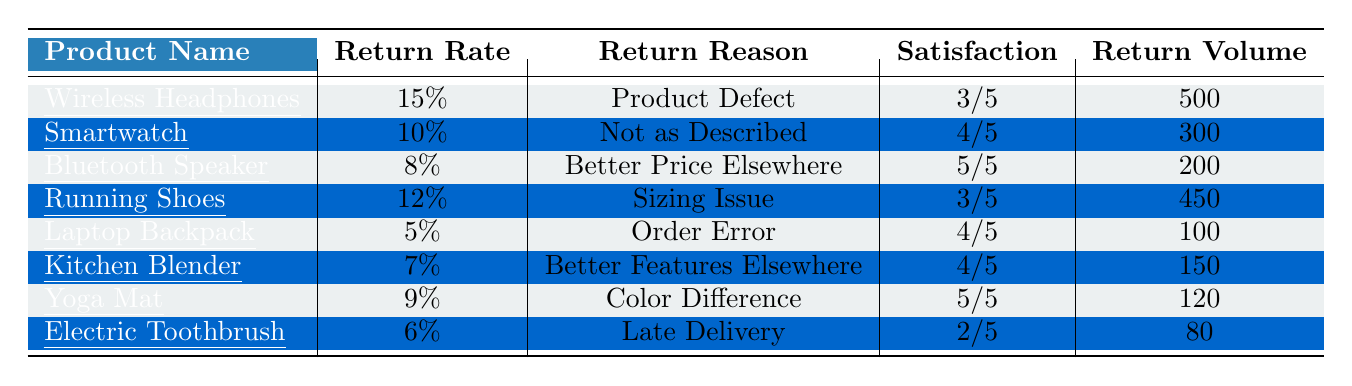What is the return rate for Wireless Headphones? The table directly lists the return rate for Wireless Headphones as 15%.
Answer: 15% What is the return reason for the Smartwatch? The return reason for the Smartwatch, as stated in the table, is "Not as Described."
Answer: Not as Described Which product has the highest customer satisfaction score? The customer satisfaction scores in the table show that the Bluetooth Speaker and the Yoga Mat both have the highest score of 5.
Answer: Bluetooth Speaker and Yoga Mat How many products have a return rate greater than 10%? By checking the return rates in the table, we find that Wireless Headphones (15%) and Running Shoes (12%) meet this condition, totaling 2 products.
Answer: 2 What is the combined return volume of the Kitchen Blender and Yoga Mat? The return volumes for Kitchen Blender and Yoga Mat are 150 and 120 respectively. Adding these gives 150 + 120 = 270.
Answer: 270 Is the return reason for Electric Toothbrush related to delivery issues? The return reason for Electric Toothbrush is "Late Delivery," which indicates a delivery issue. Therefore, the answer is yes.
Answer: Yes What is the average customer satisfaction score for the products listed? The customer satisfaction scores are 3, 4, 5, 3, 4, 4, 5, and 2. Summing these gives 30, and dividing by 8 gives an average score of 3.75.
Answer: 3.75 Which product has the lowest return volume? The table shows that the Electric Toothbrush has the lowest return volume at 80.
Answer: Electric Toothbrush How many products have a return rate below 8%? According to the table, only the Laptop Backpack (5%) and Electric Toothbrush (6%) have return rates below 8%, which totals 2 products.
Answer: 2 What is the difference in return rates between the Wireless Headphones and the Laptop Backpack? The return rate for Wireless Headphones is 15% and for Laptop Backpack is 5%. The difference is 15% - 5% = 10%.
Answer: 10% 